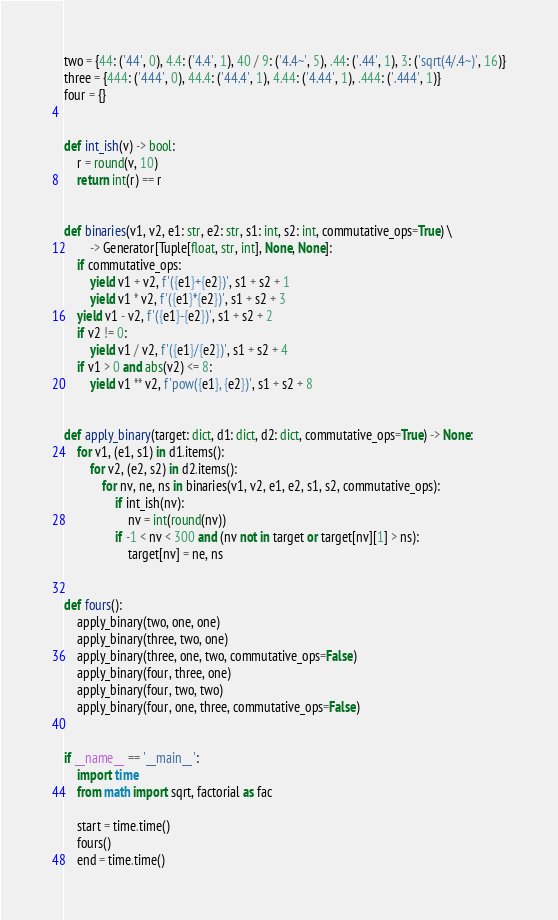<code> <loc_0><loc_0><loc_500><loc_500><_Python_>two = {44: ('44', 0), 4.4: ('4.4', 1), 40 / 9: ('4.4~', 5), .44: ('.44', 1), 3: ('sqrt(4/.4~)', 16)}
three = {444: ('444', 0), 44.4: ('44.4', 1), 4.44: ('4.44', 1), .444: ('.444', 1)}
four = {}


def int_ish(v) -> bool:
    r = round(v, 10)
    return int(r) == r


def binaries(v1, v2, e1: str, e2: str, s1: int, s2: int, commutative_ops=True) \
        -> Generator[Tuple[float, str, int], None, None]:
    if commutative_ops:
        yield v1 + v2, f'({e1}+{e2})', s1 + s2 + 1
        yield v1 * v2, f'({e1}*{e2})', s1 + s2 + 3
    yield v1 - v2, f'({e1}-{e2})', s1 + s2 + 2
    if v2 != 0:
        yield v1 / v2, f'({e1}/{e2})', s1 + s2 + 4
    if v1 > 0 and abs(v2) <= 8:
        yield v1 ** v2, f'pow({e1}, {e2})', s1 + s2 + 8


def apply_binary(target: dict, d1: dict, d2: dict, commutative_ops=True) -> None:
    for v1, (e1, s1) in d1.items():
        for v2, (e2, s2) in d2.items():
            for nv, ne, ns in binaries(v1, v2, e1, e2, s1, s2, commutative_ops):
                if int_ish(nv):
                    nv = int(round(nv))
                if -1 < nv < 300 and (nv not in target or target[nv][1] > ns):
                    target[nv] = ne, ns


def fours():
    apply_binary(two, one, one)
    apply_binary(three, two, one)
    apply_binary(three, one, two, commutative_ops=False)
    apply_binary(four, three, one)
    apply_binary(four, two, two)
    apply_binary(four, one, three, commutative_ops=False)


if __name__ == '__main__':
    import time
    from math import sqrt, factorial as fac

    start = time.time()
    fours()
    end = time.time()
</code> 